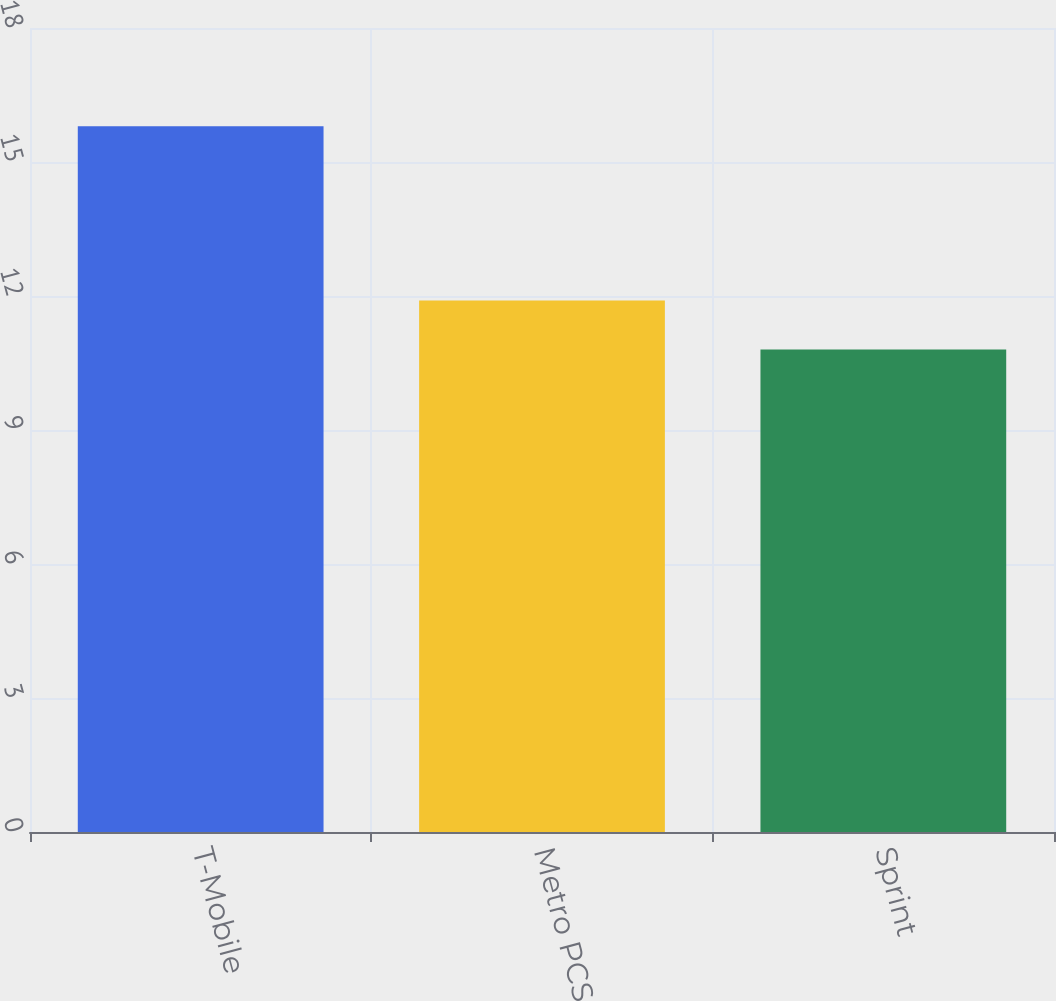Convert chart. <chart><loc_0><loc_0><loc_500><loc_500><bar_chart><fcel>T-Mobile<fcel>Metro PCS<fcel>Sprint<nl><fcel>15.8<fcel>11.9<fcel>10.8<nl></chart> 